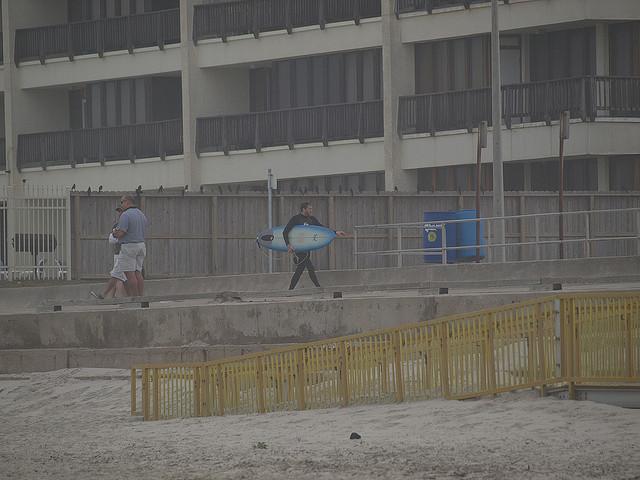What is the person holding?
Answer briefly. Surfboard. Are there garbage cans present?
Quick response, please. Yes. What season is it?
Answer briefly. Summer. How many windows?
Keep it brief. 25. How many pillars?
Be succinct. 0. What color are the man's shorts?
Concise answer only. White. Are they at the beach?
Concise answer only. Yes. How many people are visible?
Short answer required. 3. 